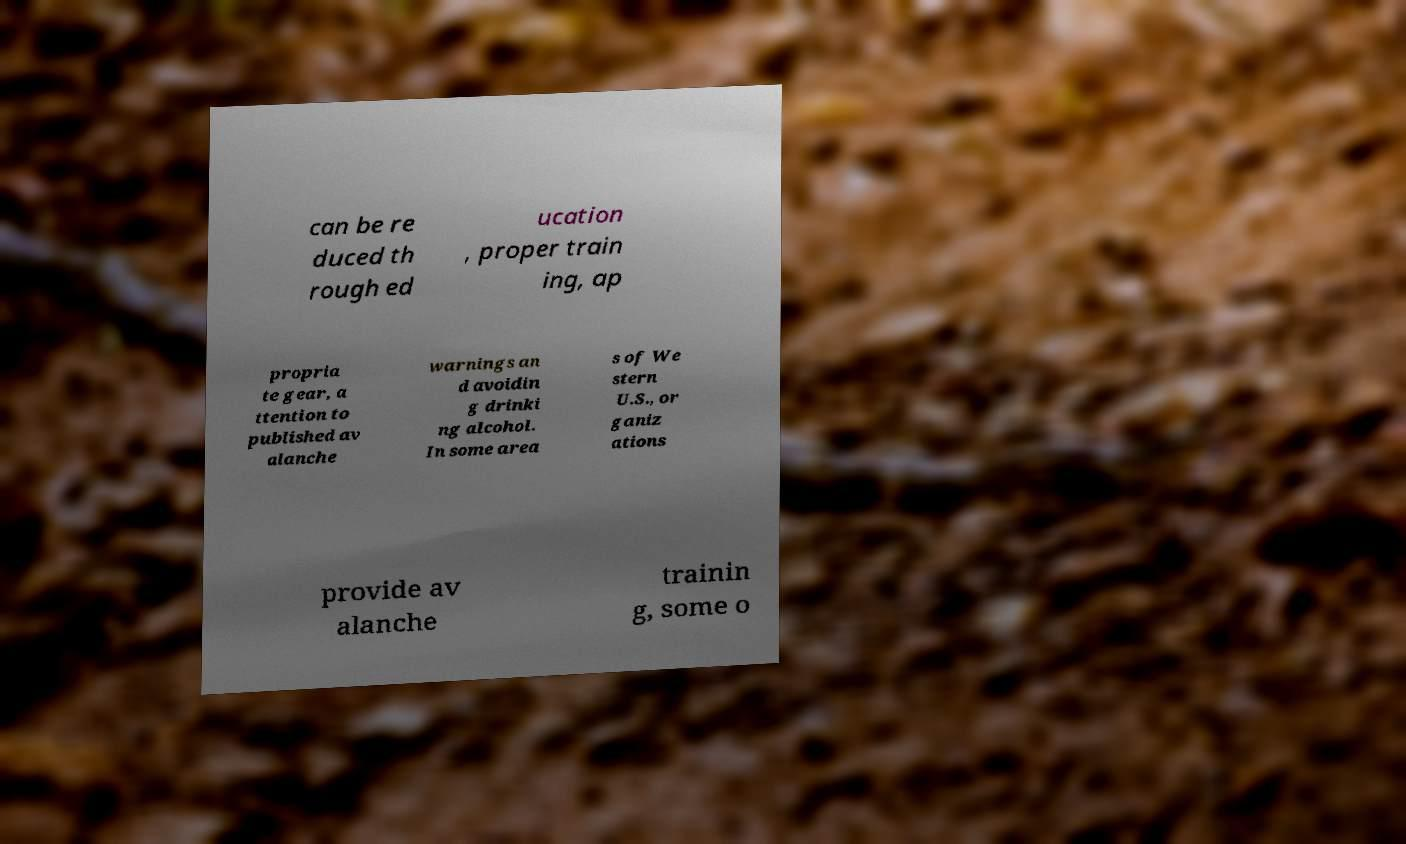I need the written content from this picture converted into text. Can you do that? can be re duced th rough ed ucation , proper train ing, ap propria te gear, a ttention to published av alanche warnings an d avoidin g drinki ng alcohol. In some area s of We stern U.S., or ganiz ations provide av alanche trainin g, some o 